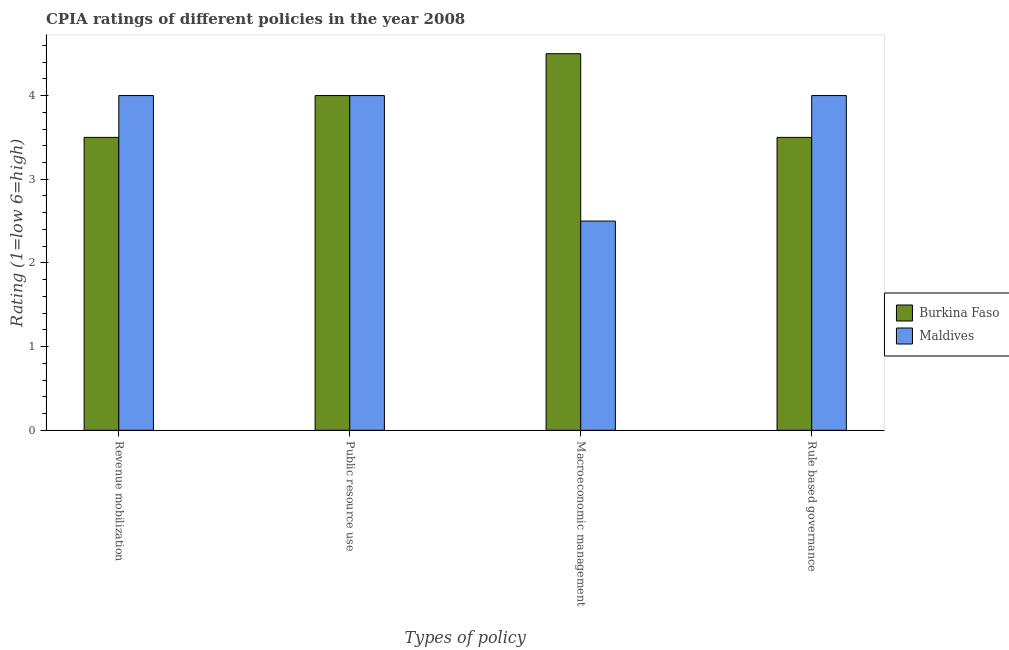How many groups of bars are there?
Offer a terse response. 4. Are the number of bars on each tick of the X-axis equal?
Offer a terse response. Yes. What is the label of the 2nd group of bars from the left?
Give a very brief answer. Public resource use. Across all countries, what is the minimum cpia rating of macroeconomic management?
Your response must be concise. 2.5. In which country was the cpia rating of macroeconomic management maximum?
Make the answer very short. Burkina Faso. In which country was the cpia rating of rule based governance minimum?
Provide a succinct answer. Burkina Faso. What is the average cpia rating of revenue mobilization per country?
Offer a very short reply. 3.75. In how many countries, is the cpia rating of rule based governance greater than 2 ?
Make the answer very short. 2. What is the ratio of the cpia rating of rule based governance in Burkina Faso to that in Maldives?
Your answer should be very brief. 0.88. What is the difference between the highest and the second highest cpia rating of macroeconomic management?
Your response must be concise. 2. What is the difference between the highest and the lowest cpia rating of macroeconomic management?
Offer a terse response. 2. Is the sum of the cpia rating of revenue mobilization in Burkina Faso and Maldives greater than the maximum cpia rating of public resource use across all countries?
Ensure brevity in your answer.  Yes. What does the 1st bar from the left in Rule based governance represents?
Keep it short and to the point. Burkina Faso. What does the 1st bar from the right in Rule based governance represents?
Your answer should be very brief. Maldives. Are all the bars in the graph horizontal?
Provide a short and direct response. No. How many countries are there in the graph?
Keep it short and to the point. 2. What is the difference between two consecutive major ticks on the Y-axis?
Ensure brevity in your answer.  1. Are the values on the major ticks of Y-axis written in scientific E-notation?
Keep it short and to the point. No. Where does the legend appear in the graph?
Give a very brief answer. Center right. How many legend labels are there?
Ensure brevity in your answer.  2. How are the legend labels stacked?
Offer a very short reply. Vertical. What is the title of the graph?
Your answer should be compact. CPIA ratings of different policies in the year 2008. What is the label or title of the X-axis?
Ensure brevity in your answer.  Types of policy. What is the Rating (1=low 6=high) of Maldives in Revenue mobilization?
Give a very brief answer. 4. What is the Rating (1=low 6=high) in Maldives in Public resource use?
Offer a very short reply. 4. What is the Rating (1=low 6=high) in Burkina Faso in Macroeconomic management?
Your answer should be compact. 4.5. What is the Rating (1=low 6=high) of Burkina Faso in Rule based governance?
Your answer should be compact. 3.5. Across all Types of policy, what is the maximum Rating (1=low 6=high) of Maldives?
Keep it short and to the point. 4. Across all Types of policy, what is the minimum Rating (1=low 6=high) of Burkina Faso?
Ensure brevity in your answer.  3.5. What is the total Rating (1=low 6=high) in Burkina Faso in the graph?
Your answer should be very brief. 15.5. What is the total Rating (1=low 6=high) of Maldives in the graph?
Your response must be concise. 14.5. What is the difference between the Rating (1=low 6=high) in Burkina Faso in Revenue mobilization and that in Public resource use?
Your response must be concise. -0.5. What is the difference between the Rating (1=low 6=high) in Maldives in Revenue mobilization and that in Public resource use?
Ensure brevity in your answer.  0. What is the difference between the Rating (1=low 6=high) in Burkina Faso in Revenue mobilization and that in Rule based governance?
Your answer should be compact. 0. What is the difference between the Rating (1=low 6=high) of Maldives in Revenue mobilization and that in Rule based governance?
Provide a short and direct response. 0. What is the difference between the Rating (1=low 6=high) of Burkina Faso in Public resource use and that in Rule based governance?
Make the answer very short. 0.5. What is the difference between the Rating (1=low 6=high) of Burkina Faso in Macroeconomic management and that in Rule based governance?
Give a very brief answer. 1. What is the difference between the Rating (1=low 6=high) of Burkina Faso in Revenue mobilization and the Rating (1=low 6=high) of Maldives in Public resource use?
Keep it short and to the point. -0.5. What is the difference between the Rating (1=low 6=high) of Burkina Faso in Revenue mobilization and the Rating (1=low 6=high) of Maldives in Macroeconomic management?
Your response must be concise. 1. What is the difference between the Rating (1=low 6=high) in Burkina Faso in Revenue mobilization and the Rating (1=low 6=high) in Maldives in Rule based governance?
Make the answer very short. -0.5. What is the difference between the Rating (1=low 6=high) in Burkina Faso in Public resource use and the Rating (1=low 6=high) in Maldives in Macroeconomic management?
Provide a short and direct response. 1.5. What is the difference between the Rating (1=low 6=high) of Burkina Faso in Public resource use and the Rating (1=low 6=high) of Maldives in Rule based governance?
Keep it short and to the point. 0. What is the difference between the Rating (1=low 6=high) of Burkina Faso in Macroeconomic management and the Rating (1=low 6=high) of Maldives in Rule based governance?
Your answer should be very brief. 0.5. What is the average Rating (1=low 6=high) of Burkina Faso per Types of policy?
Make the answer very short. 3.88. What is the average Rating (1=low 6=high) in Maldives per Types of policy?
Offer a very short reply. 3.62. What is the difference between the Rating (1=low 6=high) in Burkina Faso and Rating (1=low 6=high) in Maldives in Revenue mobilization?
Provide a short and direct response. -0.5. What is the difference between the Rating (1=low 6=high) of Burkina Faso and Rating (1=low 6=high) of Maldives in Public resource use?
Keep it short and to the point. 0. What is the difference between the Rating (1=low 6=high) in Burkina Faso and Rating (1=low 6=high) in Maldives in Macroeconomic management?
Your response must be concise. 2. What is the ratio of the Rating (1=low 6=high) in Burkina Faso in Revenue mobilization to that in Rule based governance?
Your answer should be compact. 1. What is the ratio of the Rating (1=low 6=high) of Maldives in Revenue mobilization to that in Rule based governance?
Your response must be concise. 1. What is the ratio of the Rating (1=low 6=high) in Burkina Faso in Public resource use to that in Macroeconomic management?
Your response must be concise. 0.89. What is the ratio of the Rating (1=low 6=high) of Maldives in Public resource use to that in Macroeconomic management?
Keep it short and to the point. 1.6. What is the ratio of the Rating (1=low 6=high) of Maldives in Macroeconomic management to that in Rule based governance?
Your answer should be very brief. 0.62. What is the difference between the highest and the second highest Rating (1=low 6=high) of Burkina Faso?
Keep it short and to the point. 0.5. What is the difference between the highest and the lowest Rating (1=low 6=high) of Burkina Faso?
Your response must be concise. 1. What is the difference between the highest and the lowest Rating (1=low 6=high) of Maldives?
Ensure brevity in your answer.  1.5. 